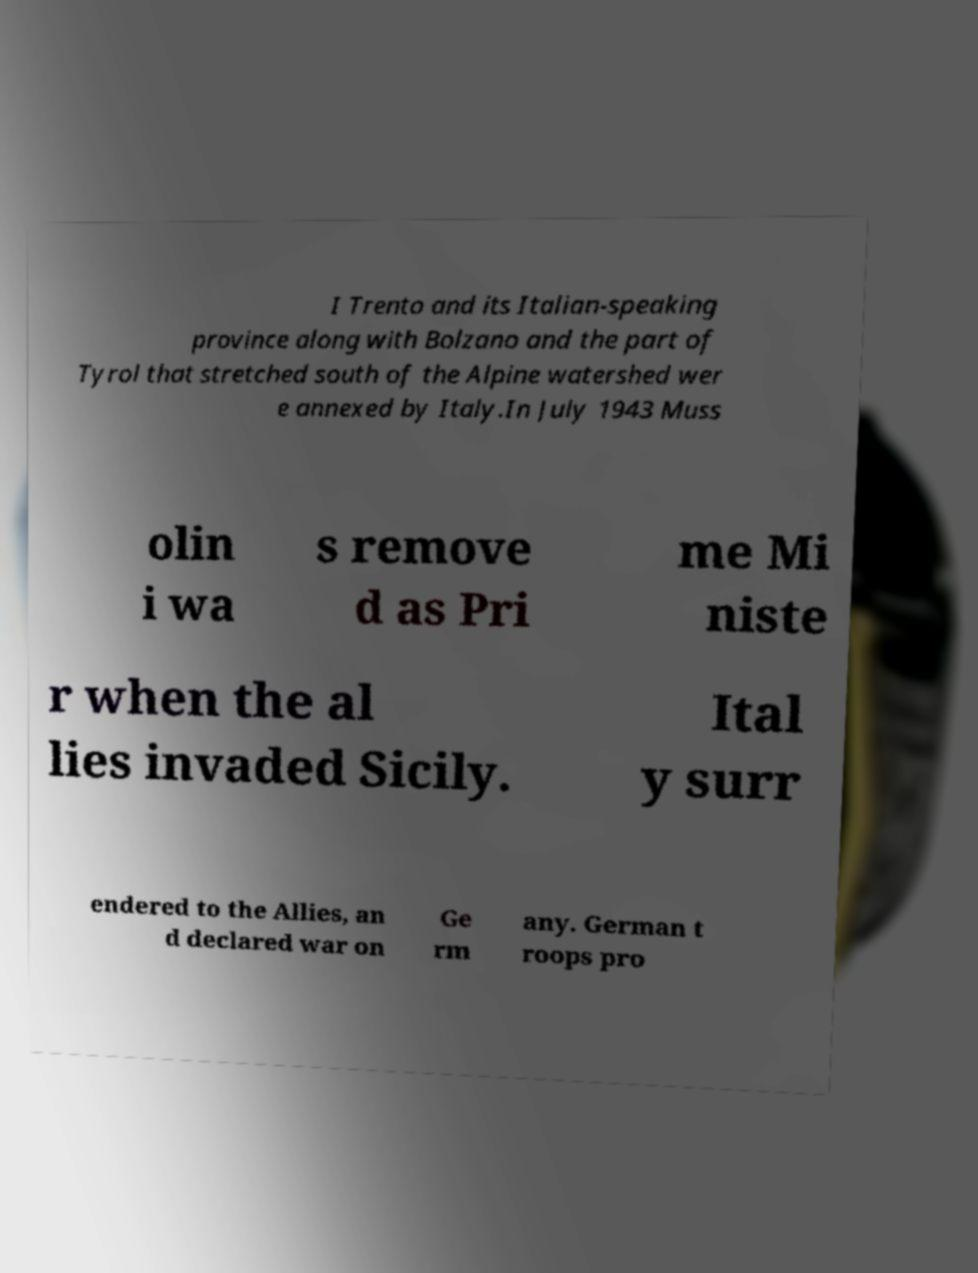For documentation purposes, I need the text within this image transcribed. Could you provide that? I Trento and its Italian-speaking province along with Bolzano and the part of Tyrol that stretched south of the Alpine watershed wer e annexed by Italy.In July 1943 Muss olin i wa s remove d as Pri me Mi niste r when the al lies invaded Sicily. Ital y surr endered to the Allies, an d declared war on Ge rm any. German t roops pro 